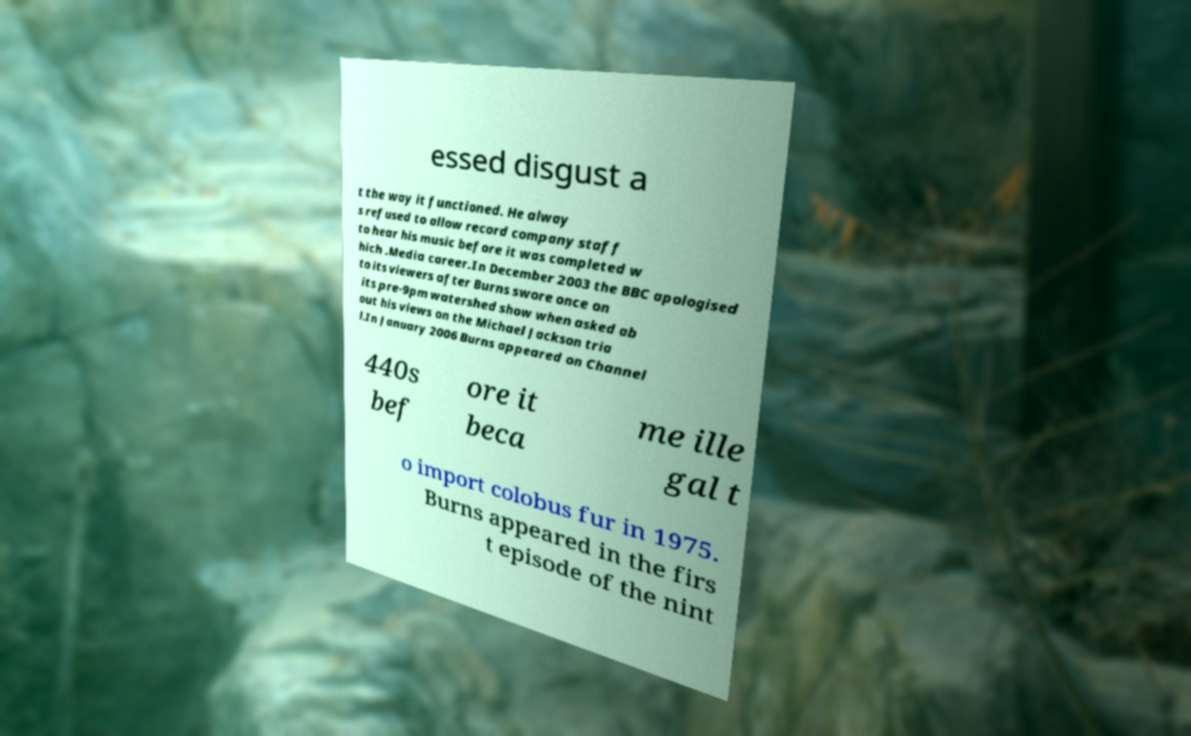Could you extract and type out the text from this image? essed disgust a t the way it functioned. He alway s refused to allow record company staff to hear his music before it was completed w hich .Media career.In December 2003 the BBC apologised to its viewers after Burns swore once on its pre-9pm watershed show when asked ab out his views on the Michael Jackson tria l.In January 2006 Burns appeared on Channel 440s bef ore it beca me ille gal t o import colobus fur in 1975. Burns appeared in the firs t episode of the nint 